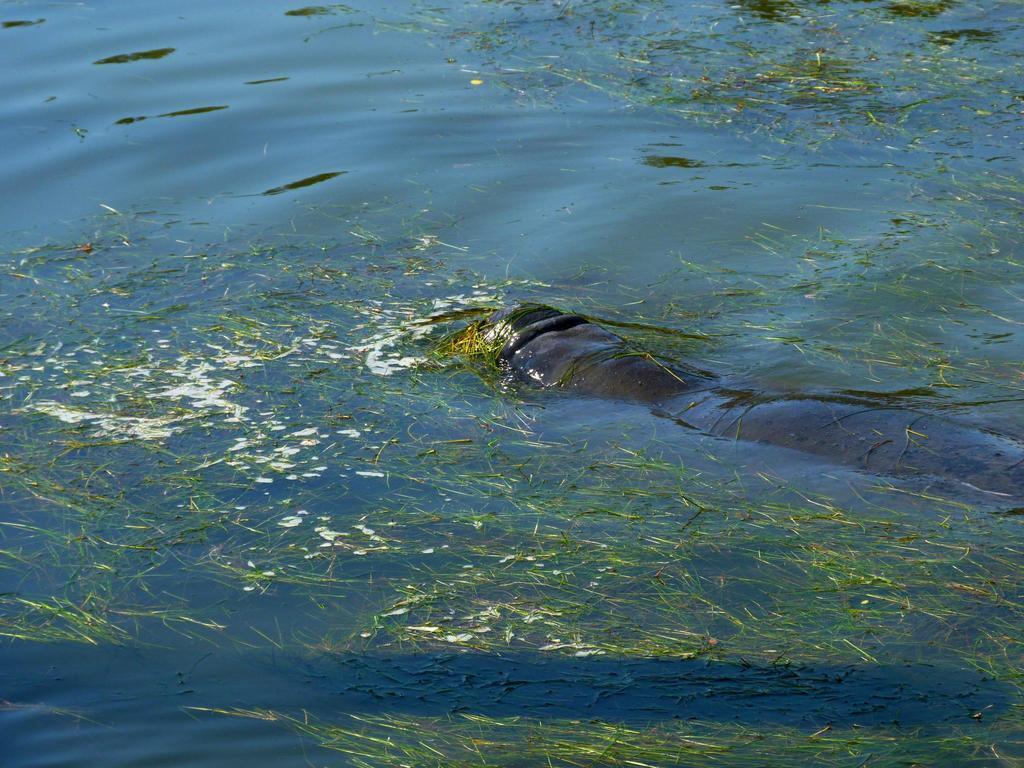How would you summarize this image in a sentence or two? In this image we can see an animal in the water and some green leaves floating on the water. 